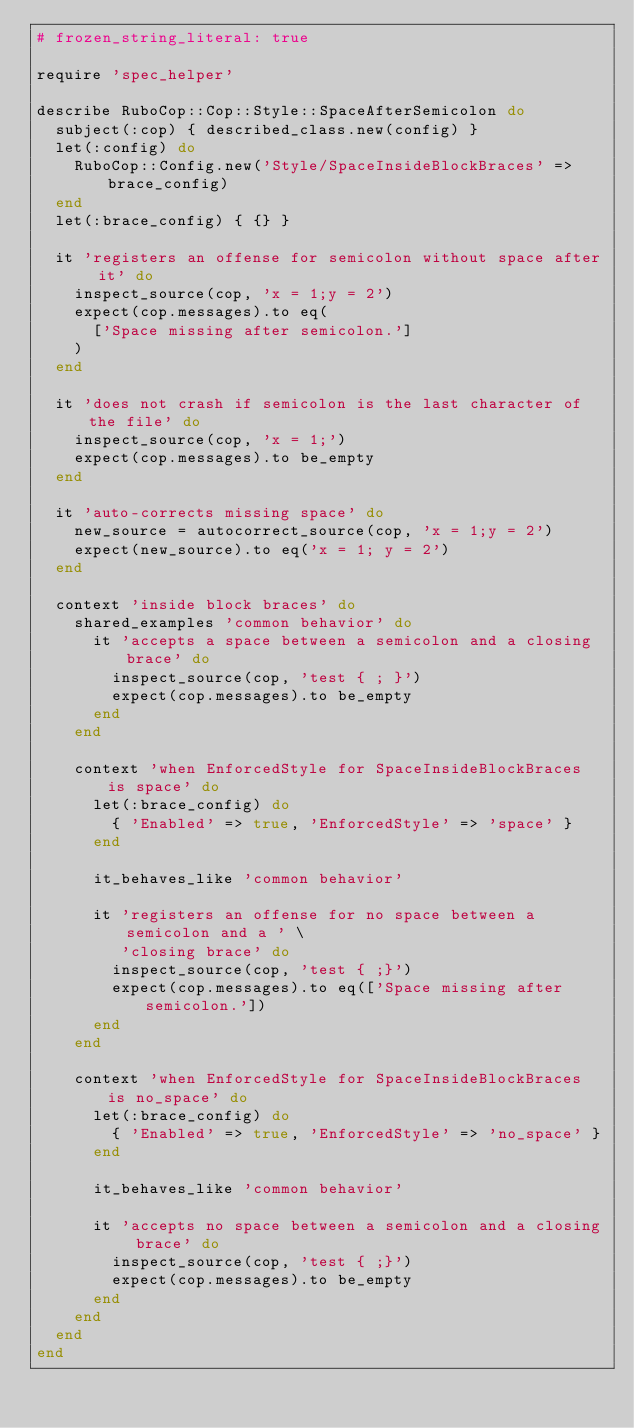<code> <loc_0><loc_0><loc_500><loc_500><_Ruby_># frozen_string_literal: true

require 'spec_helper'

describe RuboCop::Cop::Style::SpaceAfterSemicolon do
  subject(:cop) { described_class.new(config) }
  let(:config) do
    RuboCop::Config.new('Style/SpaceInsideBlockBraces' => brace_config)
  end
  let(:brace_config) { {} }

  it 'registers an offense for semicolon without space after it' do
    inspect_source(cop, 'x = 1;y = 2')
    expect(cop.messages).to eq(
      ['Space missing after semicolon.']
    )
  end

  it 'does not crash if semicolon is the last character of the file' do
    inspect_source(cop, 'x = 1;')
    expect(cop.messages).to be_empty
  end

  it 'auto-corrects missing space' do
    new_source = autocorrect_source(cop, 'x = 1;y = 2')
    expect(new_source).to eq('x = 1; y = 2')
  end

  context 'inside block braces' do
    shared_examples 'common behavior' do
      it 'accepts a space between a semicolon and a closing brace' do
        inspect_source(cop, 'test { ; }')
        expect(cop.messages).to be_empty
      end
    end

    context 'when EnforcedStyle for SpaceInsideBlockBraces is space' do
      let(:brace_config) do
        { 'Enabled' => true, 'EnforcedStyle' => 'space' }
      end

      it_behaves_like 'common behavior'

      it 'registers an offense for no space between a semicolon and a ' \
         'closing brace' do
        inspect_source(cop, 'test { ;}')
        expect(cop.messages).to eq(['Space missing after semicolon.'])
      end
    end

    context 'when EnforcedStyle for SpaceInsideBlockBraces is no_space' do
      let(:brace_config) do
        { 'Enabled' => true, 'EnforcedStyle' => 'no_space' }
      end

      it_behaves_like 'common behavior'

      it 'accepts no space between a semicolon and a closing brace' do
        inspect_source(cop, 'test { ;}')
        expect(cop.messages).to be_empty
      end
    end
  end
end
</code> 